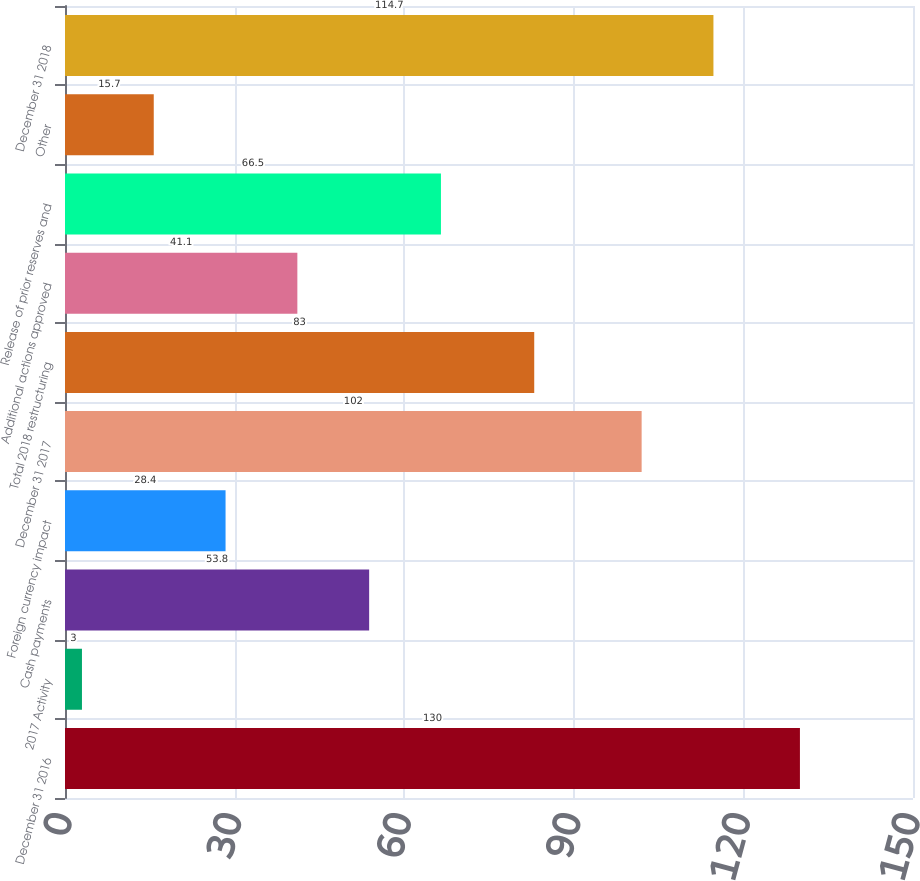Convert chart. <chart><loc_0><loc_0><loc_500><loc_500><bar_chart><fcel>December 31 2016<fcel>2017 Activity<fcel>Cash payments<fcel>Foreign currency impact<fcel>December 31 2017<fcel>Total 2018 restructuring<fcel>Additional actions approved<fcel>Release of prior reserves and<fcel>Other<fcel>December 31 2018<nl><fcel>130<fcel>3<fcel>53.8<fcel>28.4<fcel>102<fcel>83<fcel>41.1<fcel>66.5<fcel>15.7<fcel>114.7<nl></chart> 